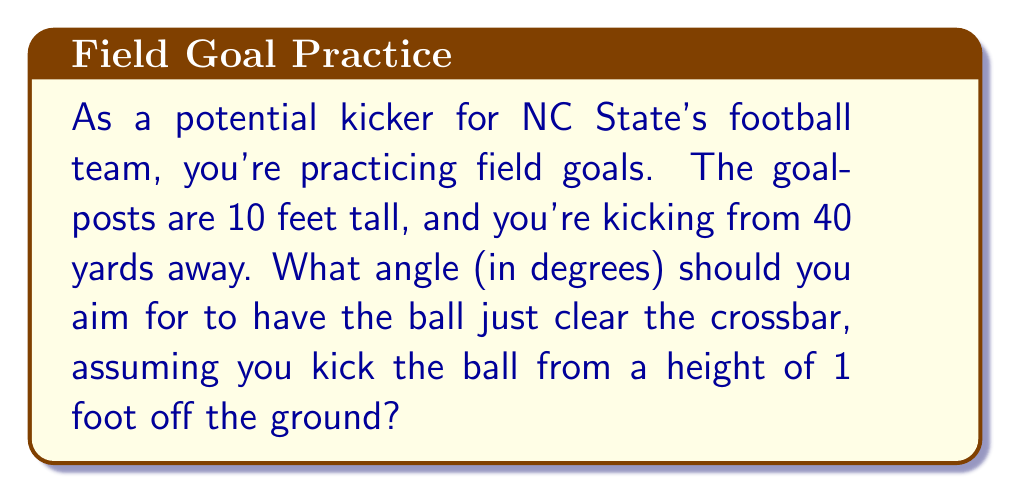Can you solve this math problem? Let's approach this step-by-step using trigonometry:

1) First, we need to convert all measurements to the same unit. Let's use feet:
   40 yards = 120 feet
   Goalpost height = 10 feet
   Initial kick height = 1 foot

2) We need to find the angle of elevation from the kicker to the top of the goalpost. Let's call this angle $\theta$.

3) We can visualize this as a right triangle:
   - The base of the triangle is 120 feet (distance to the goalpost)
   - The height of the triangle is 9 feet (10 feet goalpost height minus 1 foot initial kick height)

4) We can use the tangent function to find this angle:

   $$\tan(\theta) = \frac{\text{opposite}}{\text{adjacent}} = \frac{9}{120}$$

5) To solve for $\theta$, we use the inverse tangent (arctan or $\tan^{-1}$):

   $$\theta = \tan^{-1}(\frac{9}{120})$$

6) Using a calculator or computer:

   $$\theta \approx 4.29^\circ$$

7) Round to two decimal places for practical use.

[asy]
import geometry;

size(200);
pair A=(0,0), B=(120,0), C=(120,9);
draw(A--B--C--A);
label("120 ft", (60,0), S);
label("9 ft", (120,4.5), E);
label("θ", (5,1), NW);
dot("Kicker", A, SW);
dot("Goalpost", (120,10), NE);
[/asy]
Answer: $4.29^\circ$ 